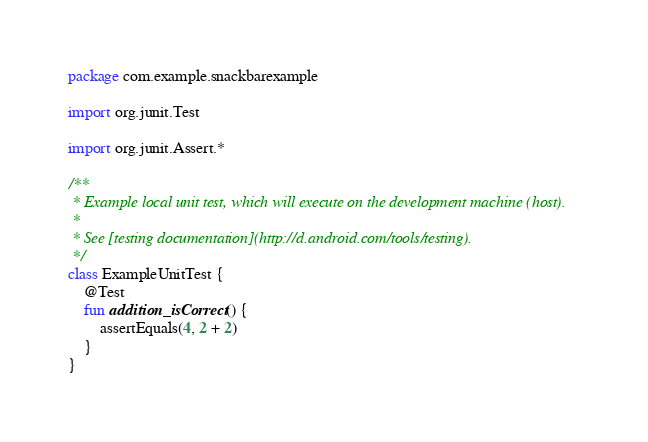Convert code to text. <code><loc_0><loc_0><loc_500><loc_500><_Kotlin_>package com.example.snackbarexample

import org.junit.Test

import org.junit.Assert.*

/**
 * Example local unit test, which will execute on the development machine (host).
 *
 * See [testing documentation](http://d.android.com/tools/testing).
 */
class ExampleUnitTest {
    @Test
    fun addition_isCorrect() {
        assertEquals(4, 2 + 2)
    }
}
</code> 